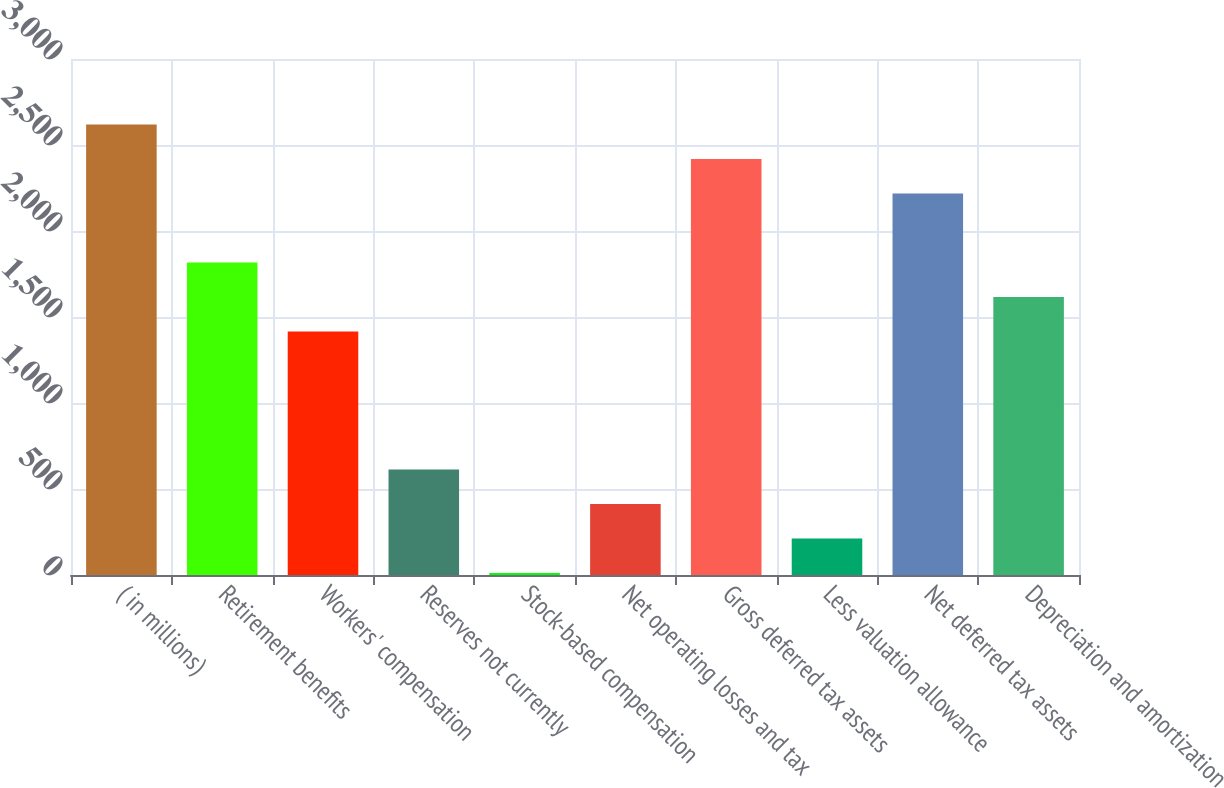<chart> <loc_0><loc_0><loc_500><loc_500><bar_chart><fcel>( in millions)<fcel>Retirement benefits<fcel>Workers' compensation<fcel>Reserves not currently<fcel>Stock-based compensation<fcel>Net operating losses and tax<fcel>Gross deferred tax assets<fcel>Less valuation allowance<fcel>Net deferred tax assets<fcel>Depreciation and amortization<nl><fcel>2618.8<fcel>1816.4<fcel>1415.2<fcel>612.8<fcel>11<fcel>412.2<fcel>2418.2<fcel>211.6<fcel>2217.6<fcel>1615.8<nl></chart> 